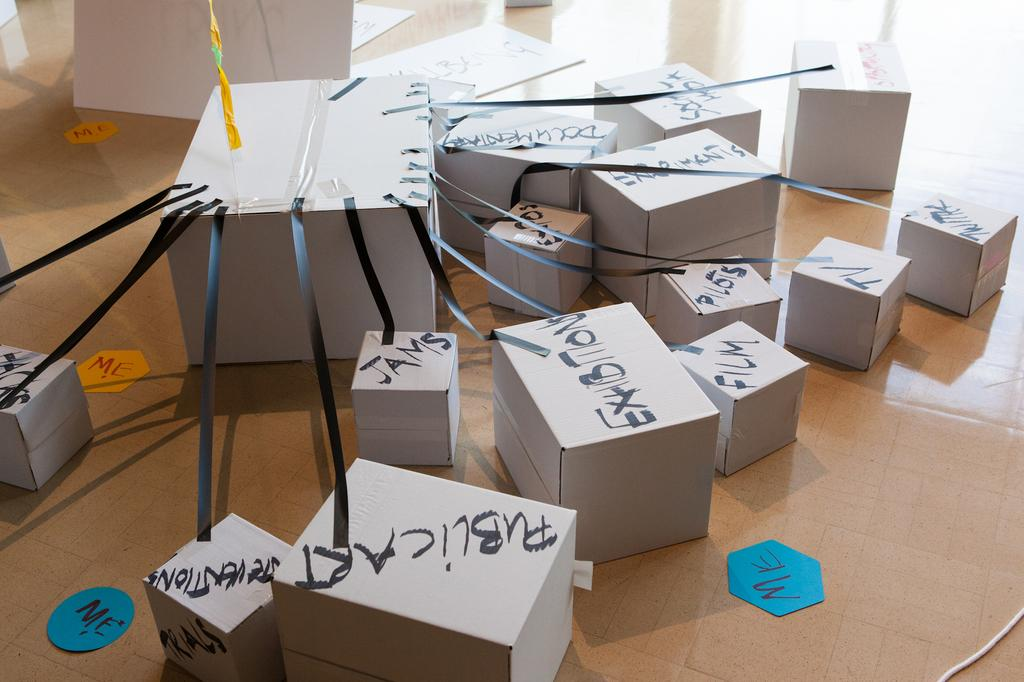<image>
Give a short and clear explanation of the subsequent image. One large white box connected to a series of other boxes meant to show the connection between a person and activities or things. 